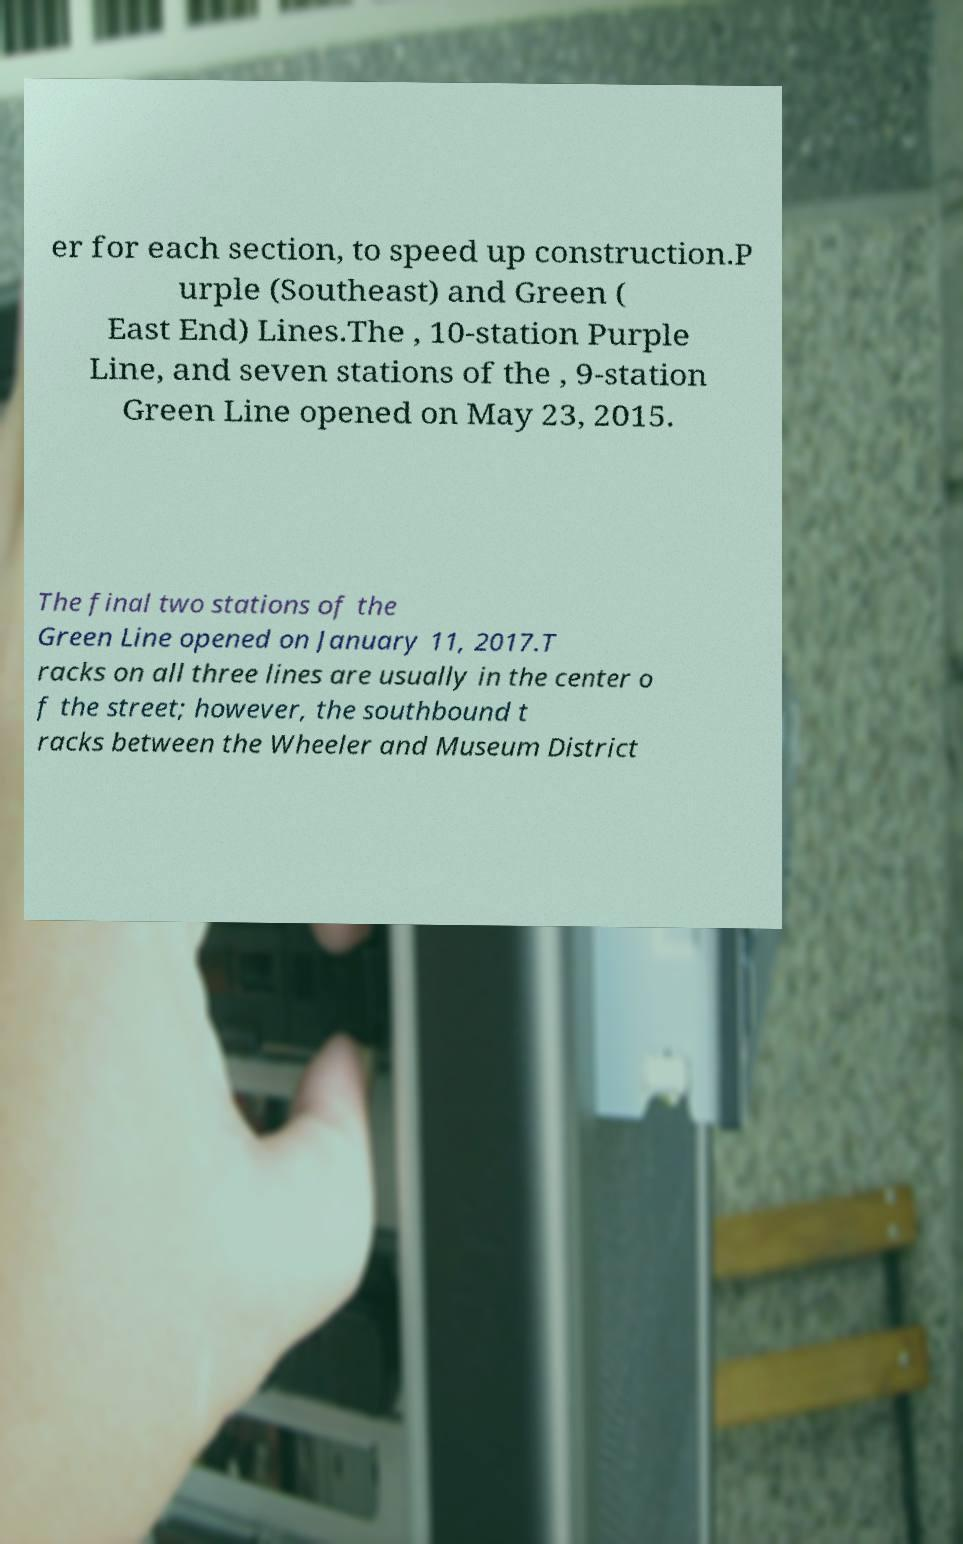Please identify and transcribe the text found in this image. er for each section, to speed up construction.P urple (Southeast) and Green ( East End) Lines.The , 10-station Purple Line, and seven stations of the , 9-station Green Line opened on May 23, 2015. The final two stations of the Green Line opened on January 11, 2017.T racks on all three lines are usually in the center o f the street; however, the southbound t racks between the Wheeler and Museum District 